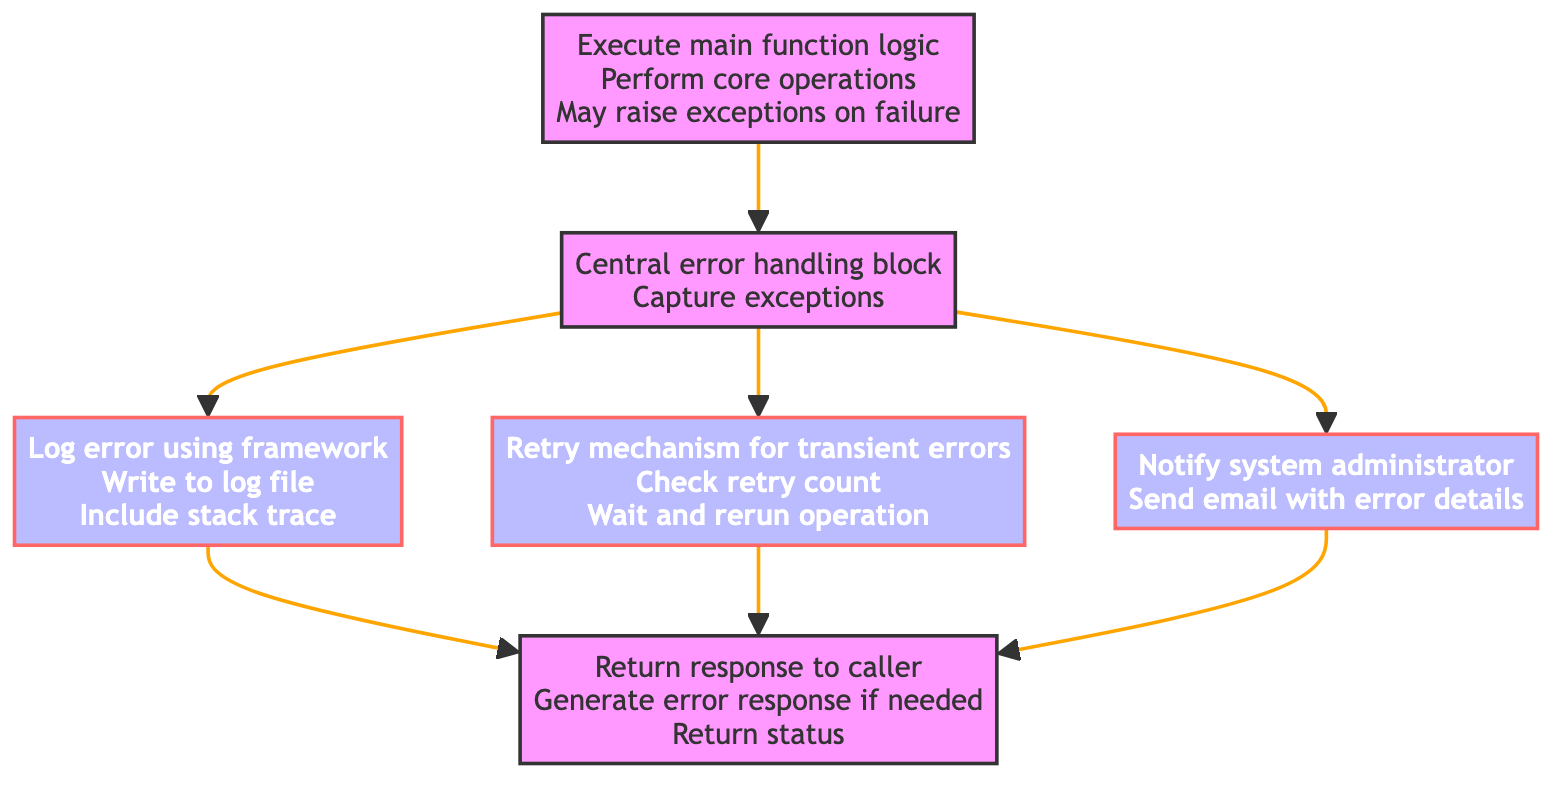What is the first block in the flowchart? The first block in the flowchart is "Execute main function logic". This corresponds to the bottom element of the flowchart, indicating the starting point of the function's process.
Answer: Execute main function logic How many blocks are there in the diagram? There are a total of six blocks in the diagram. Each block represents a specific action or aspect of the exception handling and logging system.
Answer: Six What action follows the central error handling block? After the central error handling block, the actions that follow are logging the error, retrying the operation, and notifying the administrator. This indicates that the error handling block leads to multiple subsequent actions.
Answer: Log error, retry operation, notify administrator Which block incorporates stack trace information? The block titled "Log error using framework" includes the action of including stack trace information when logging an error, as per its description.
Answer: Log error using framework What happens after logging the error? After logging the error, either the retry operation mechanism is executed, or the system notifies the administrator. This flow indicates that the logging block leads to two potential actions depending on the severity of the error.
Answer: Retry operation, notify administrator How does the flowchart handle transient errors? Transient errors are handled by the "Retry mechanism for transient errors" block which checks the retry count, waits for a short delay, and then attempts to rerun the operation. This shows a conditional approach to error recovery.
Answer: Retry mechanism for transient errors What is the final action taken in the flowchart? The final action taken in the flowchart is returning the response to the caller, indicating the end of the process after handling the exception. This signifies that after all error handling, a result is provided.
Answer: Return response to caller How is a system administrator notified in case of critical errors? A system administrator is notified by composing and sending a notification email with the error details through the "Notify system administrator" block. This illustrates the communication strategy for critical issues.
Answer: Notify system administrator What condition is checked by the retry operation block? The retry operation block checks the retry count, determining if another attempt should be made at executing the operation or if it should proceed to notify the administrator. This evaluation helps manage transient issues efficiently.
Answer: Check retry count 